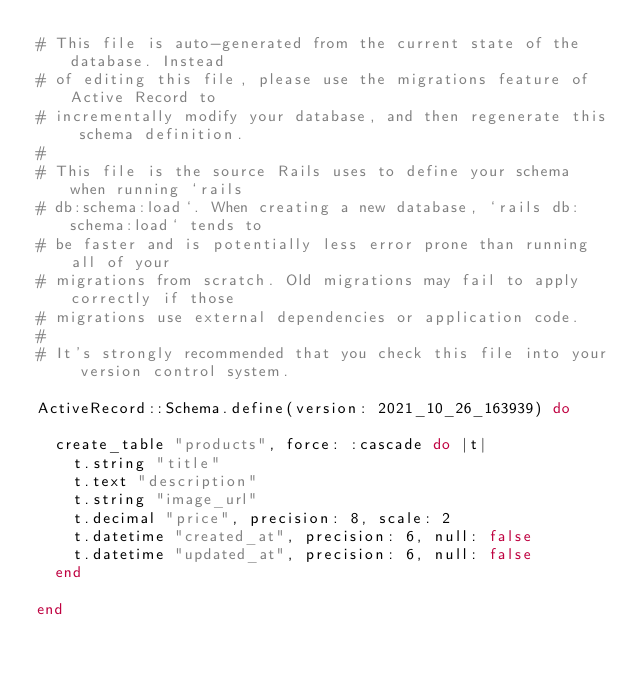<code> <loc_0><loc_0><loc_500><loc_500><_Ruby_># This file is auto-generated from the current state of the database. Instead
# of editing this file, please use the migrations feature of Active Record to
# incrementally modify your database, and then regenerate this schema definition.
#
# This file is the source Rails uses to define your schema when running `rails
# db:schema:load`. When creating a new database, `rails db:schema:load` tends to
# be faster and is potentially less error prone than running all of your
# migrations from scratch. Old migrations may fail to apply correctly if those
# migrations use external dependencies or application code.
#
# It's strongly recommended that you check this file into your version control system.

ActiveRecord::Schema.define(version: 2021_10_26_163939) do

  create_table "products", force: :cascade do |t|
    t.string "title"
    t.text "description"
    t.string "image_url"
    t.decimal "price", precision: 8, scale: 2
    t.datetime "created_at", precision: 6, null: false
    t.datetime "updated_at", precision: 6, null: false
  end

end
</code> 